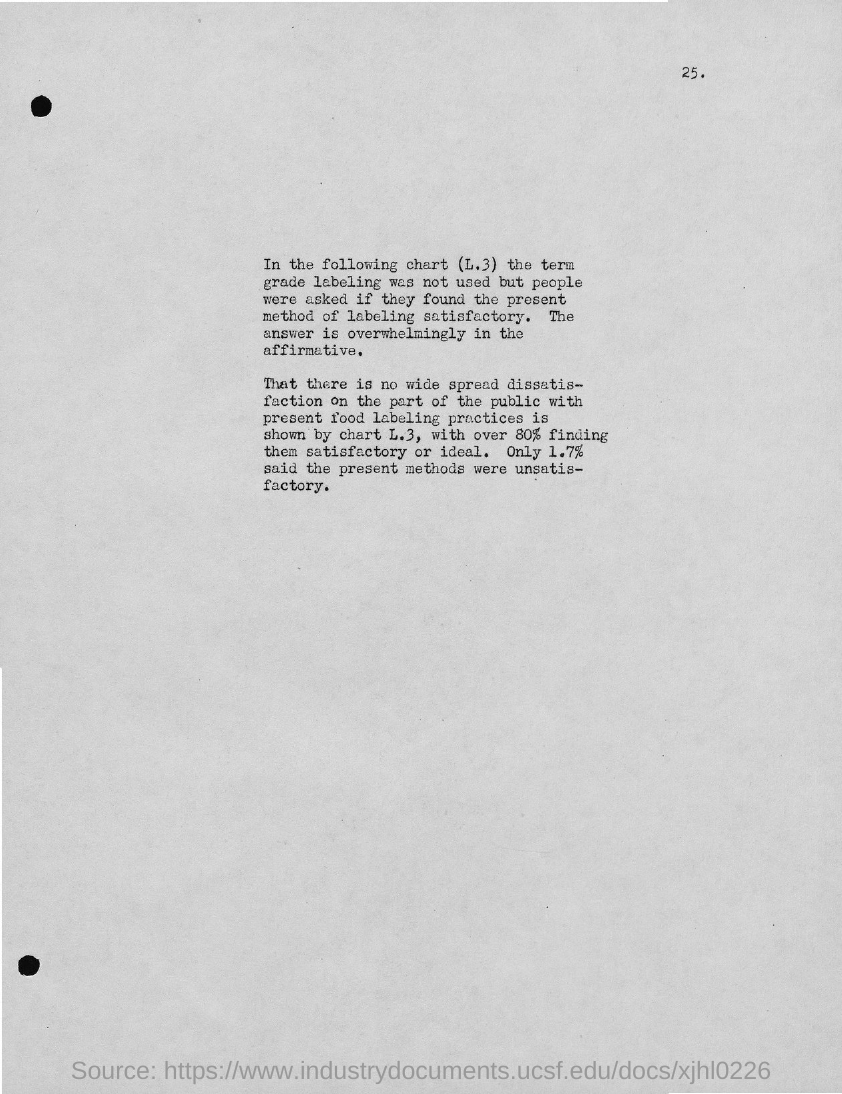Mention a couple of crucial points in this snapshot. The page number is 25. 